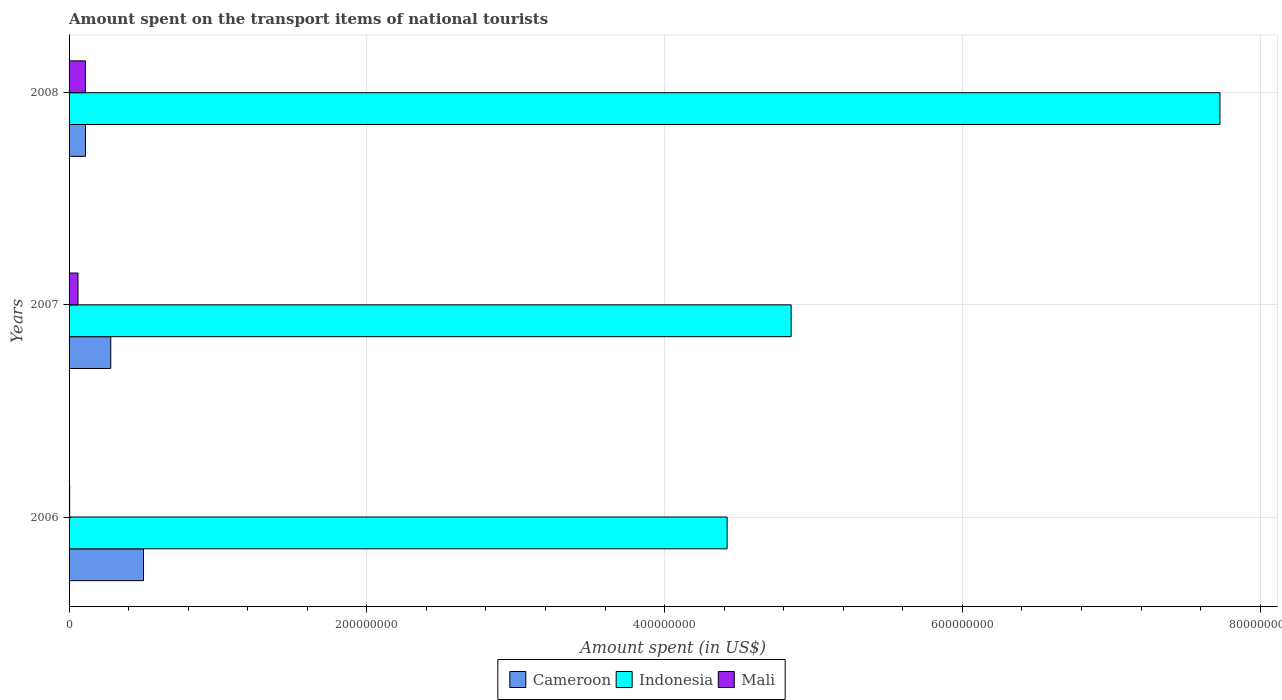How many different coloured bars are there?
Offer a terse response. 3. How many groups of bars are there?
Your answer should be very brief. 3. How many bars are there on the 1st tick from the bottom?
Provide a succinct answer. 3. What is the amount spent on the transport items of national tourists in Cameroon in 2007?
Provide a short and direct response. 2.80e+07. Across all years, what is the maximum amount spent on the transport items of national tourists in Indonesia?
Make the answer very short. 7.73e+08. Across all years, what is the minimum amount spent on the transport items of national tourists in Indonesia?
Your response must be concise. 4.42e+08. In which year was the amount spent on the transport items of national tourists in Mali maximum?
Your response must be concise. 2008. In which year was the amount spent on the transport items of national tourists in Mali minimum?
Make the answer very short. 2006. What is the total amount spent on the transport items of national tourists in Indonesia in the graph?
Provide a short and direct response. 1.70e+09. What is the difference between the amount spent on the transport items of national tourists in Mali in 2007 and that in 2008?
Provide a succinct answer. -5.00e+06. What is the difference between the amount spent on the transport items of national tourists in Cameroon in 2006 and the amount spent on the transport items of national tourists in Mali in 2008?
Provide a short and direct response. 3.90e+07. What is the average amount spent on the transport items of national tourists in Indonesia per year?
Your answer should be compact. 5.67e+08. In the year 2007, what is the difference between the amount spent on the transport items of national tourists in Indonesia and amount spent on the transport items of national tourists in Cameroon?
Offer a very short reply. 4.57e+08. What is the ratio of the amount spent on the transport items of national tourists in Mali in 2006 to that in 2007?
Provide a succinct answer. 0.07. Is the difference between the amount spent on the transport items of national tourists in Indonesia in 2006 and 2008 greater than the difference between the amount spent on the transport items of national tourists in Cameroon in 2006 and 2008?
Ensure brevity in your answer.  No. What is the difference between the highest and the lowest amount spent on the transport items of national tourists in Mali?
Provide a short and direct response. 1.06e+07. In how many years, is the amount spent on the transport items of national tourists in Mali greater than the average amount spent on the transport items of national tourists in Mali taken over all years?
Keep it short and to the point. 2. What does the 2nd bar from the top in 2007 represents?
Your answer should be very brief. Indonesia. Is it the case that in every year, the sum of the amount spent on the transport items of national tourists in Cameroon and amount spent on the transport items of national tourists in Indonesia is greater than the amount spent on the transport items of national tourists in Mali?
Provide a short and direct response. Yes. How many bars are there?
Offer a very short reply. 9. How many years are there in the graph?
Offer a terse response. 3. How many legend labels are there?
Ensure brevity in your answer.  3. How are the legend labels stacked?
Your answer should be compact. Horizontal. What is the title of the graph?
Keep it short and to the point. Amount spent on the transport items of national tourists. What is the label or title of the X-axis?
Provide a short and direct response. Amount spent (in US$). What is the label or title of the Y-axis?
Provide a succinct answer. Years. What is the Amount spent (in US$) of Indonesia in 2006?
Give a very brief answer. 4.42e+08. What is the Amount spent (in US$) of Cameroon in 2007?
Offer a very short reply. 2.80e+07. What is the Amount spent (in US$) of Indonesia in 2007?
Give a very brief answer. 4.85e+08. What is the Amount spent (in US$) in Cameroon in 2008?
Keep it short and to the point. 1.10e+07. What is the Amount spent (in US$) in Indonesia in 2008?
Offer a very short reply. 7.73e+08. What is the Amount spent (in US$) in Mali in 2008?
Make the answer very short. 1.10e+07. Across all years, what is the maximum Amount spent (in US$) in Cameroon?
Your response must be concise. 5.00e+07. Across all years, what is the maximum Amount spent (in US$) of Indonesia?
Your response must be concise. 7.73e+08. Across all years, what is the maximum Amount spent (in US$) in Mali?
Your answer should be very brief. 1.10e+07. Across all years, what is the minimum Amount spent (in US$) in Cameroon?
Your answer should be compact. 1.10e+07. Across all years, what is the minimum Amount spent (in US$) of Indonesia?
Keep it short and to the point. 4.42e+08. Across all years, what is the minimum Amount spent (in US$) in Mali?
Your response must be concise. 4.00e+05. What is the total Amount spent (in US$) in Cameroon in the graph?
Offer a very short reply. 8.90e+07. What is the total Amount spent (in US$) in Indonesia in the graph?
Make the answer very short. 1.70e+09. What is the total Amount spent (in US$) in Mali in the graph?
Keep it short and to the point. 1.74e+07. What is the difference between the Amount spent (in US$) of Cameroon in 2006 and that in 2007?
Your answer should be compact. 2.20e+07. What is the difference between the Amount spent (in US$) of Indonesia in 2006 and that in 2007?
Keep it short and to the point. -4.30e+07. What is the difference between the Amount spent (in US$) in Mali in 2006 and that in 2007?
Keep it short and to the point. -5.60e+06. What is the difference between the Amount spent (in US$) in Cameroon in 2006 and that in 2008?
Your answer should be compact. 3.90e+07. What is the difference between the Amount spent (in US$) in Indonesia in 2006 and that in 2008?
Make the answer very short. -3.31e+08. What is the difference between the Amount spent (in US$) of Mali in 2006 and that in 2008?
Make the answer very short. -1.06e+07. What is the difference between the Amount spent (in US$) of Cameroon in 2007 and that in 2008?
Provide a short and direct response. 1.70e+07. What is the difference between the Amount spent (in US$) of Indonesia in 2007 and that in 2008?
Provide a succinct answer. -2.88e+08. What is the difference between the Amount spent (in US$) of Mali in 2007 and that in 2008?
Offer a very short reply. -5.00e+06. What is the difference between the Amount spent (in US$) of Cameroon in 2006 and the Amount spent (in US$) of Indonesia in 2007?
Ensure brevity in your answer.  -4.35e+08. What is the difference between the Amount spent (in US$) of Cameroon in 2006 and the Amount spent (in US$) of Mali in 2007?
Offer a very short reply. 4.40e+07. What is the difference between the Amount spent (in US$) in Indonesia in 2006 and the Amount spent (in US$) in Mali in 2007?
Offer a terse response. 4.36e+08. What is the difference between the Amount spent (in US$) of Cameroon in 2006 and the Amount spent (in US$) of Indonesia in 2008?
Offer a terse response. -7.23e+08. What is the difference between the Amount spent (in US$) in Cameroon in 2006 and the Amount spent (in US$) in Mali in 2008?
Your response must be concise. 3.90e+07. What is the difference between the Amount spent (in US$) of Indonesia in 2006 and the Amount spent (in US$) of Mali in 2008?
Offer a terse response. 4.31e+08. What is the difference between the Amount spent (in US$) in Cameroon in 2007 and the Amount spent (in US$) in Indonesia in 2008?
Give a very brief answer. -7.45e+08. What is the difference between the Amount spent (in US$) in Cameroon in 2007 and the Amount spent (in US$) in Mali in 2008?
Offer a very short reply. 1.70e+07. What is the difference between the Amount spent (in US$) of Indonesia in 2007 and the Amount spent (in US$) of Mali in 2008?
Ensure brevity in your answer.  4.74e+08. What is the average Amount spent (in US$) of Cameroon per year?
Provide a succinct answer. 2.97e+07. What is the average Amount spent (in US$) in Indonesia per year?
Provide a succinct answer. 5.67e+08. What is the average Amount spent (in US$) of Mali per year?
Your answer should be very brief. 5.80e+06. In the year 2006, what is the difference between the Amount spent (in US$) of Cameroon and Amount spent (in US$) of Indonesia?
Ensure brevity in your answer.  -3.92e+08. In the year 2006, what is the difference between the Amount spent (in US$) in Cameroon and Amount spent (in US$) in Mali?
Your answer should be compact. 4.96e+07. In the year 2006, what is the difference between the Amount spent (in US$) of Indonesia and Amount spent (in US$) of Mali?
Make the answer very short. 4.42e+08. In the year 2007, what is the difference between the Amount spent (in US$) in Cameroon and Amount spent (in US$) in Indonesia?
Keep it short and to the point. -4.57e+08. In the year 2007, what is the difference between the Amount spent (in US$) of Cameroon and Amount spent (in US$) of Mali?
Provide a short and direct response. 2.20e+07. In the year 2007, what is the difference between the Amount spent (in US$) of Indonesia and Amount spent (in US$) of Mali?
Give a very brief answer. 4.79e+08. In the year 2008, what is the difference between the Amount spent (in US$) of Cameroon and Amount spent (in US$) of Indonesia?
Provide a succinct answer. -7.62e+08. In the year 2008, what is the difference between the Amount spent (in US$) of Indonesia and Amount spent (in US$) of Mali?
Provide a short and direct response. 7.62e+08. What is the ratio of the Amount spent (in US$) of Cameroon in 2006 to that in 2007?
Offer a terse response. 1.79. What is the ratio of the Amount spent (in US$) of Indonesia in 2006 to that in 2007?
Provide a succinct answer. 0.91. What is the ratio of the Amount spent (in US$) in Mali in 2006 to that in 2007?
Your answer should be compact. 0.07. What is the ratio of the Amount spent (in US$) of Cameroon in 2006 to that in 2008?
Ensure brevity in your answer.  4.55. What is the ratio of the Amount spent (in US$) of Indonesia in 2006 to that in 2008?
Keep it short and to the point. 0.57. What is the ratio of the Amount spent (in US$) in Mali in 2006 to that in 2008?
Your answer should be very brief. 0.04. What is the ratio of the Amount spent (in US$) in Cameroon in 2007 to that in 2008?
Keep it short and to the point. 2.55. What is the ratio of the Amount spent (in US$) of Indonesia in 2007 to that in 2008?
Your response must be concise. 0.63. What is the ratio of the Amount spent (in US$) in Mali in 2007 to that in 2008?
Give a very brief answer. 0.55. What is the difference between the highest and the second highest Amount spent (in US$) in Cameroon?
Provide a succinct answer. 2.20e+07. What is the difference between the highest and the second highest Amount spent (in US$) of Indonesia?
Provide a short and direct response. 2.88e+08. What is the difference between the highest and the lowest Amount spent (in US$) of Cameroon?
Give a very brief answer. 3.90e+07. What is the difference between the highest and the lowest Amount spent (in US$) in Indonesia?
Your response must be concise. 3.31e+08. What is the difference between the highest and the lowest Amount spent (in US$) of Mali?
Ensure brevity in your answer.  1.06e+07. 